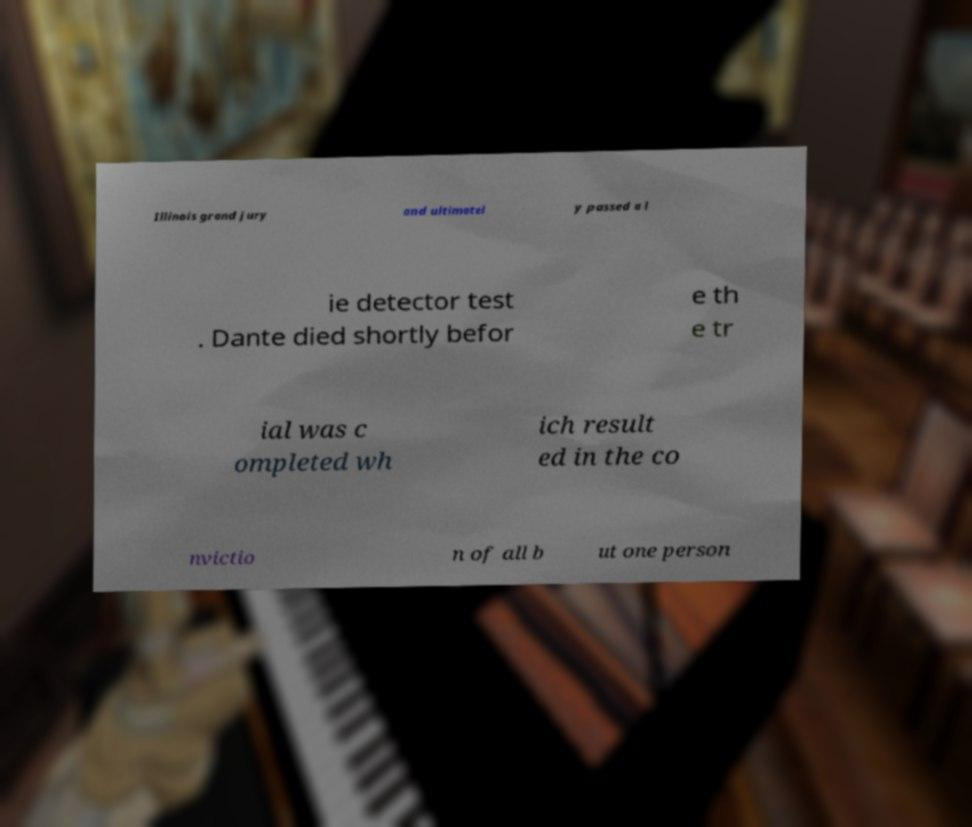Please read and relay the text visible in this image. What does it say? Illinois grand jury and ultimatel y passed a l ie detector test . Dante died shortly befor e th e tr ial was c ompleted wh ich result ed in the co nvictio n of all b ut one person 